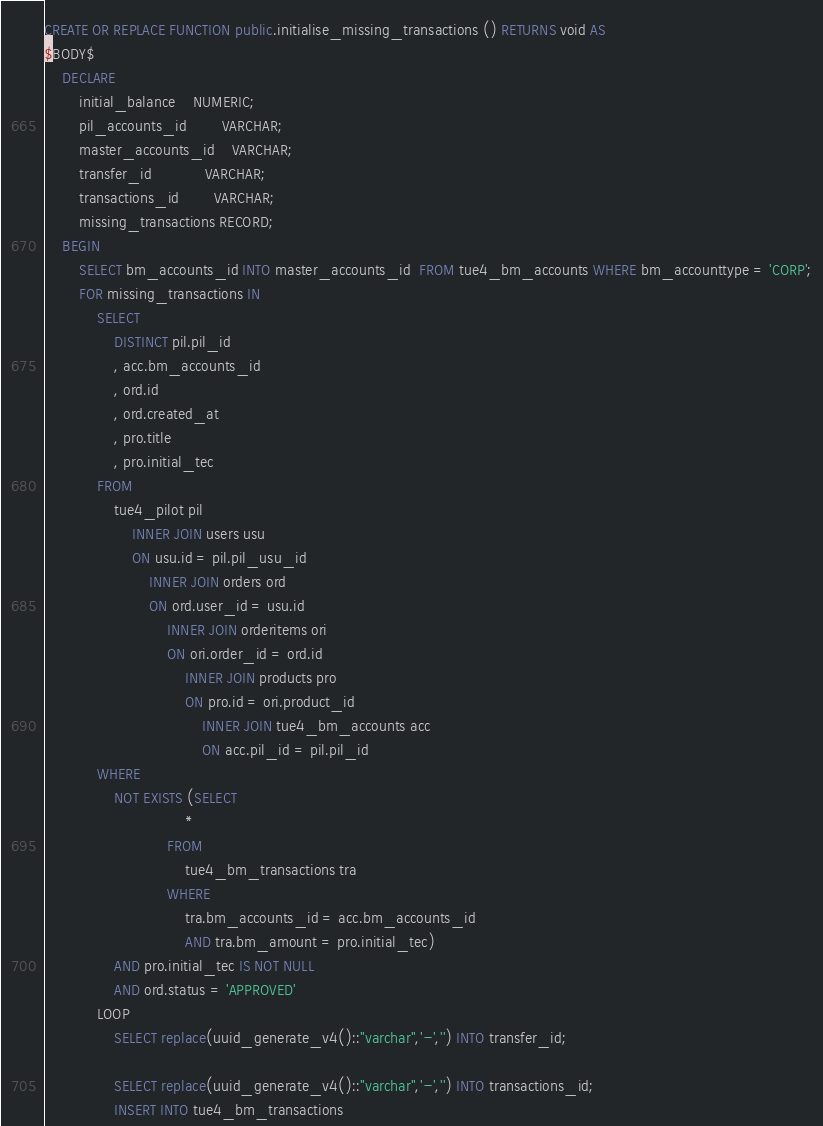Convert code to text. <code><loc_0><loc_0><loc_500><loc_500><_SQL_>
CREATE OR REPLACE FUNCTION public.initialise_missing_transactions () RETURNS void AS
$BODY$
    DECLARE
		initial_balance 	NUMERIC;
		pil_accounts_id		VARCHAR;
		master_accounts_id	VARCHAR;
		transfer_id			VARCHAR;
		transactions_id		VARCHAR;
        missing_transactions RECORD;
    BEGIN
        SELECT bm_accounts_id INTO master_accounts_id  FROM tue4_bm_accounts WHERE bm_accounttype = 'CORP';
        FOR missing_transactions IN
            SELECT
                DISTINCT pil.pil_id
                , acc.bm_accounts_id
                , ord.id
                , ord.created_at
                , pro.title
                , pro.initial_tec 
            FROM
                tue4_pilot pil 
                    INNER JOIN users usu 
                    ON usu.id = pil.pil_usu_id 
                        INNER JOIN orders ord 
                        ON ord.user_id = usu.id 
                            INNER JOIN orderitems ori 
                            ON ori.order_id = ord.id 
                                INNER JOIN products pro 
                                ON pro.id = ori.product_id 
                                    INNER JOIN tue4_bm_accounts acc 
                                    ON acc.pil_id = pil.pil_id 
            WHERE
                NOT EXISTS (SELECT
                                * 
                            FROM
                                tue4_bm_transactions tra 
                            WHERE
                                tra.bm_accounts_id = acc.bm_accounts_id 
                                AND tra.bm_amount = pro.initial_tec) 
                AND pro.initial_tec IS NOT NULL 
                AND ord.status = 'APPROVED' 
            LOOP
                SELECT replace(uuid_generate_v4()::"varchar",'-','') INTO transfer_id;

                SELECT replace(uuid_generate_v4()::"varchar",'-','') INTO transactions_id;
                INSERT INTO tue4_bm_transactions</code> 